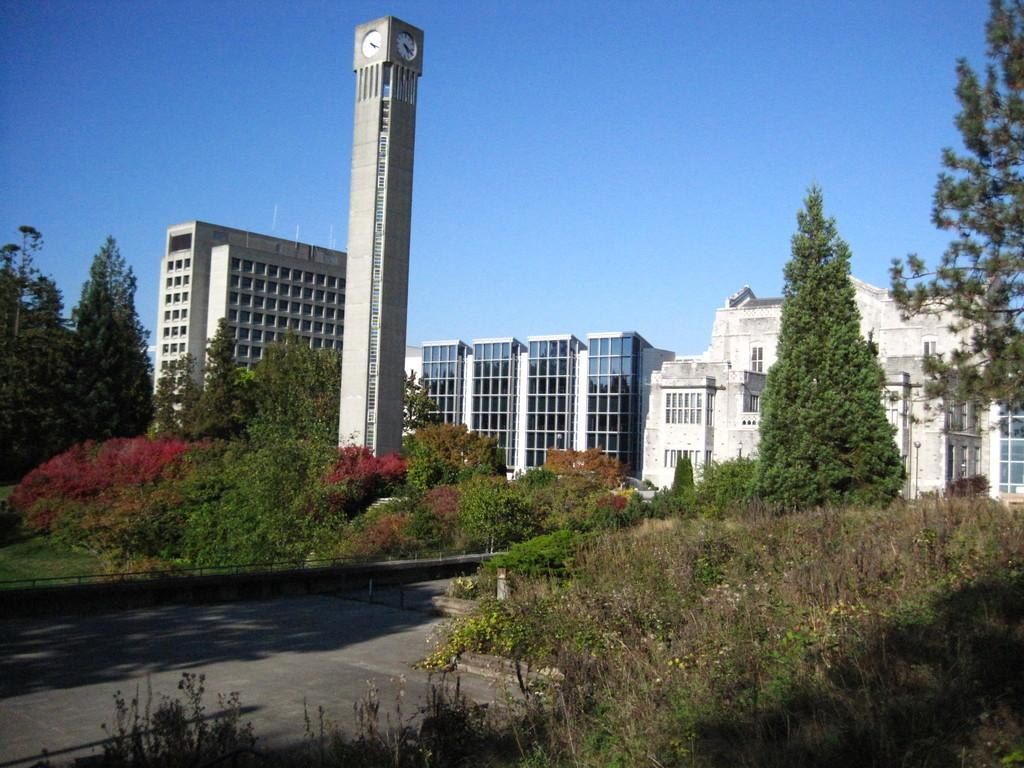What is in the foreground of the image? There is pavement in the foreground of the image. What type of vegetation is present on either side of the pavement? There is greenery on either side of the pavement. What can be seen in the background of the image? There are buildings and a tower in the background of the image. What is visible at the top of the image? The sky is visible at the top of the image. Can you find the letter "X" hidden in the greenery on the left side of the image? There is no letter "X" present in the image; it only features pavement, greenery, buildings, a tower, and the sky. Are there any clams visible on the pavement in the image? There are no clams present in the image; it only features pavement, greenery, buildings, a tower, and the sky. 